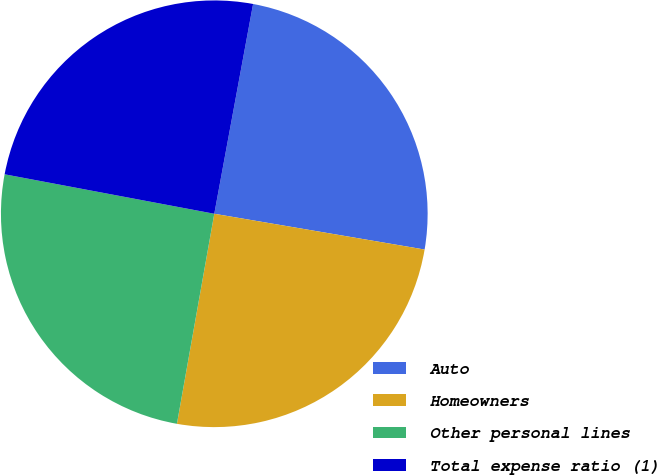Convert chart. <chart><loc_0><loc_0><loc_500><loc_500><pie_chart><fcel>Auto<fcel>Homeowners<fcel>Other personal lines<fcel>Total expense ratio (1)<nl><fcel>24.77%<fcel>25.12%<fcel>25.16%<fcel>24.95%<nl></chart> 